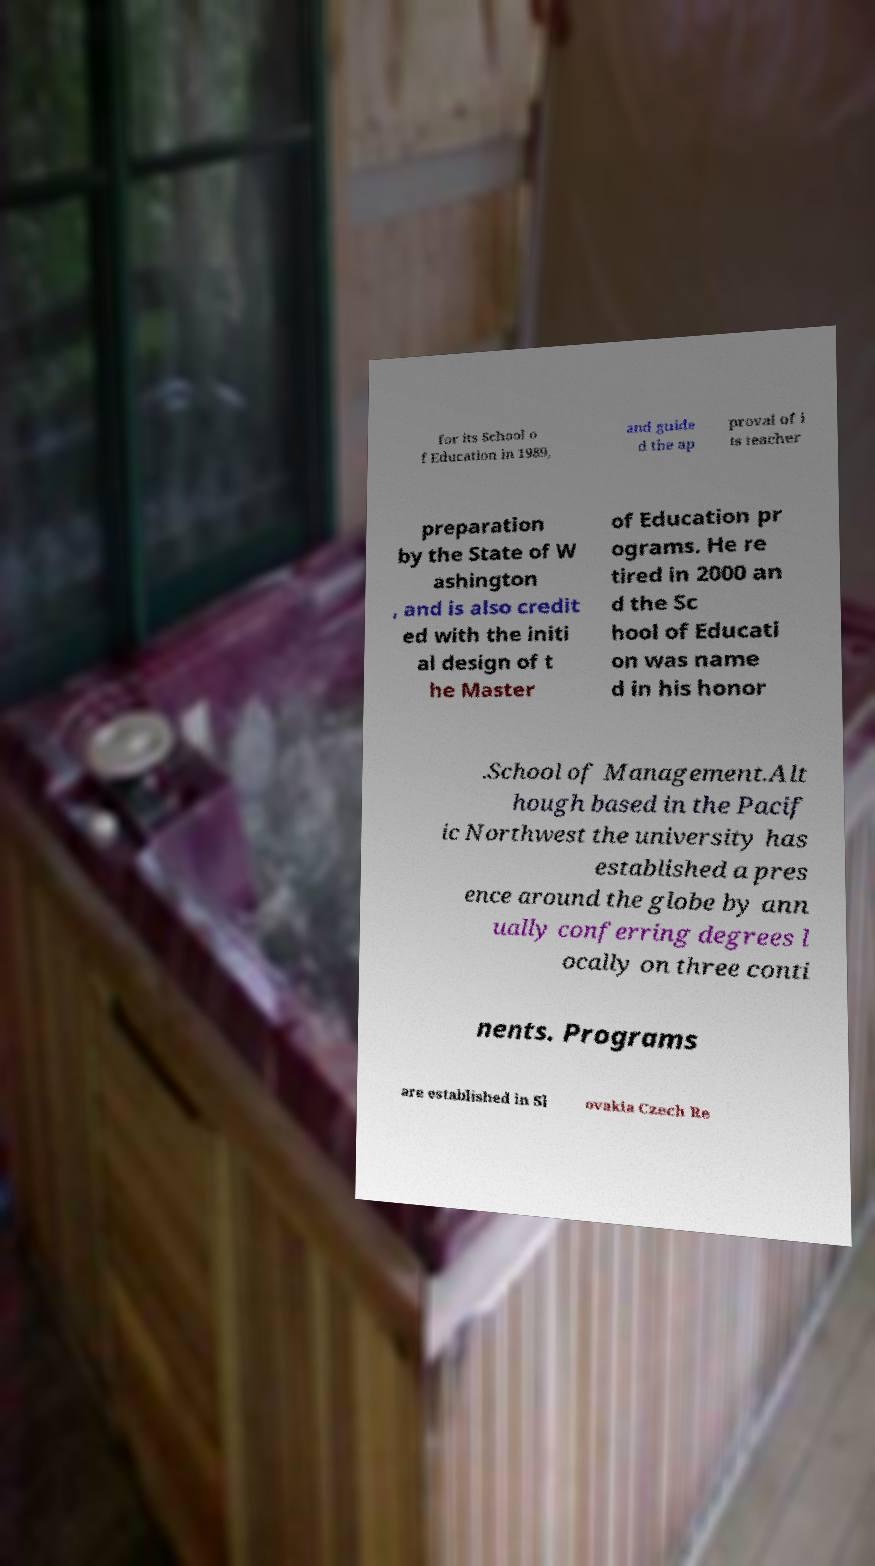Can you read and provide the text displayed in the image?This photo seems to have some interesting text. Can you extract and type it out for me? for its School o f Education in 1989, and guide d the ap proval of i ts teacher preparation by the State of W ashington , and is also credit ed with the initi al design of t he Master of Education pr ograms. He re tired in 2000 an d the Sc hool of Educati on was name d in his honor .School of Management.Alt hough based in the Pacif ic Northwest the university has established a pres ence around the globe by ann ually conferring degrees l ocally on three conti nents. Programs are established in Sl ovakia Czech Re 